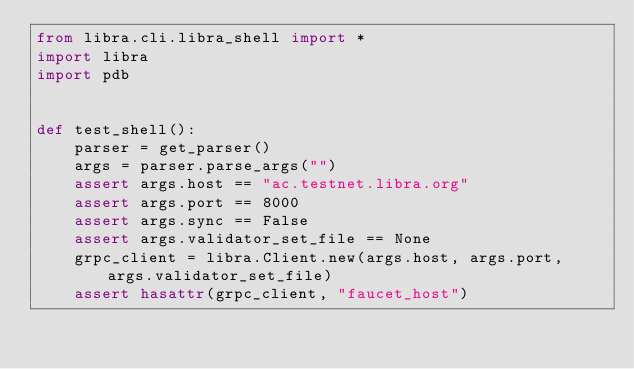<code> <loc_0><loc_0><loc_500><loc_500><_Python_>from libra.cli.libra_shell import *
import libra
import pdb


def test_shell():
    parser = get_parser()
    args = parser.parse_args("")
    assert args.host == "ac.testnet.libra.org"
    assert args.port == 8000
    assert args.sync == False
    assert args.validator_set_file == None
    grpc_client = libra.Client.new(args.host, args.port, args.validator_set_file)
    assert hasattr(grpc_client, "faucet_host")
</code> 